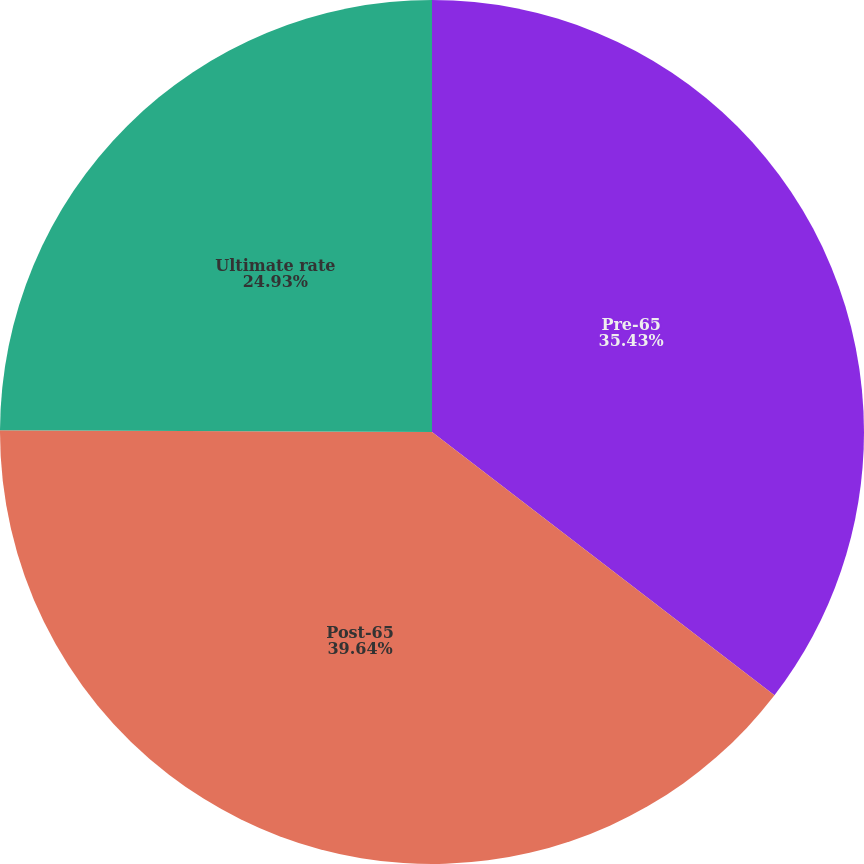<chart> <loc_0><loc_0><loc_500><loc_500><pie_chart><fcel>Pre-65<fcel>Post-65<fcel>Ultimate rate<nl><fcel>35.43%<fcel>39.63%<fcel>24.93%<nl></chart> 